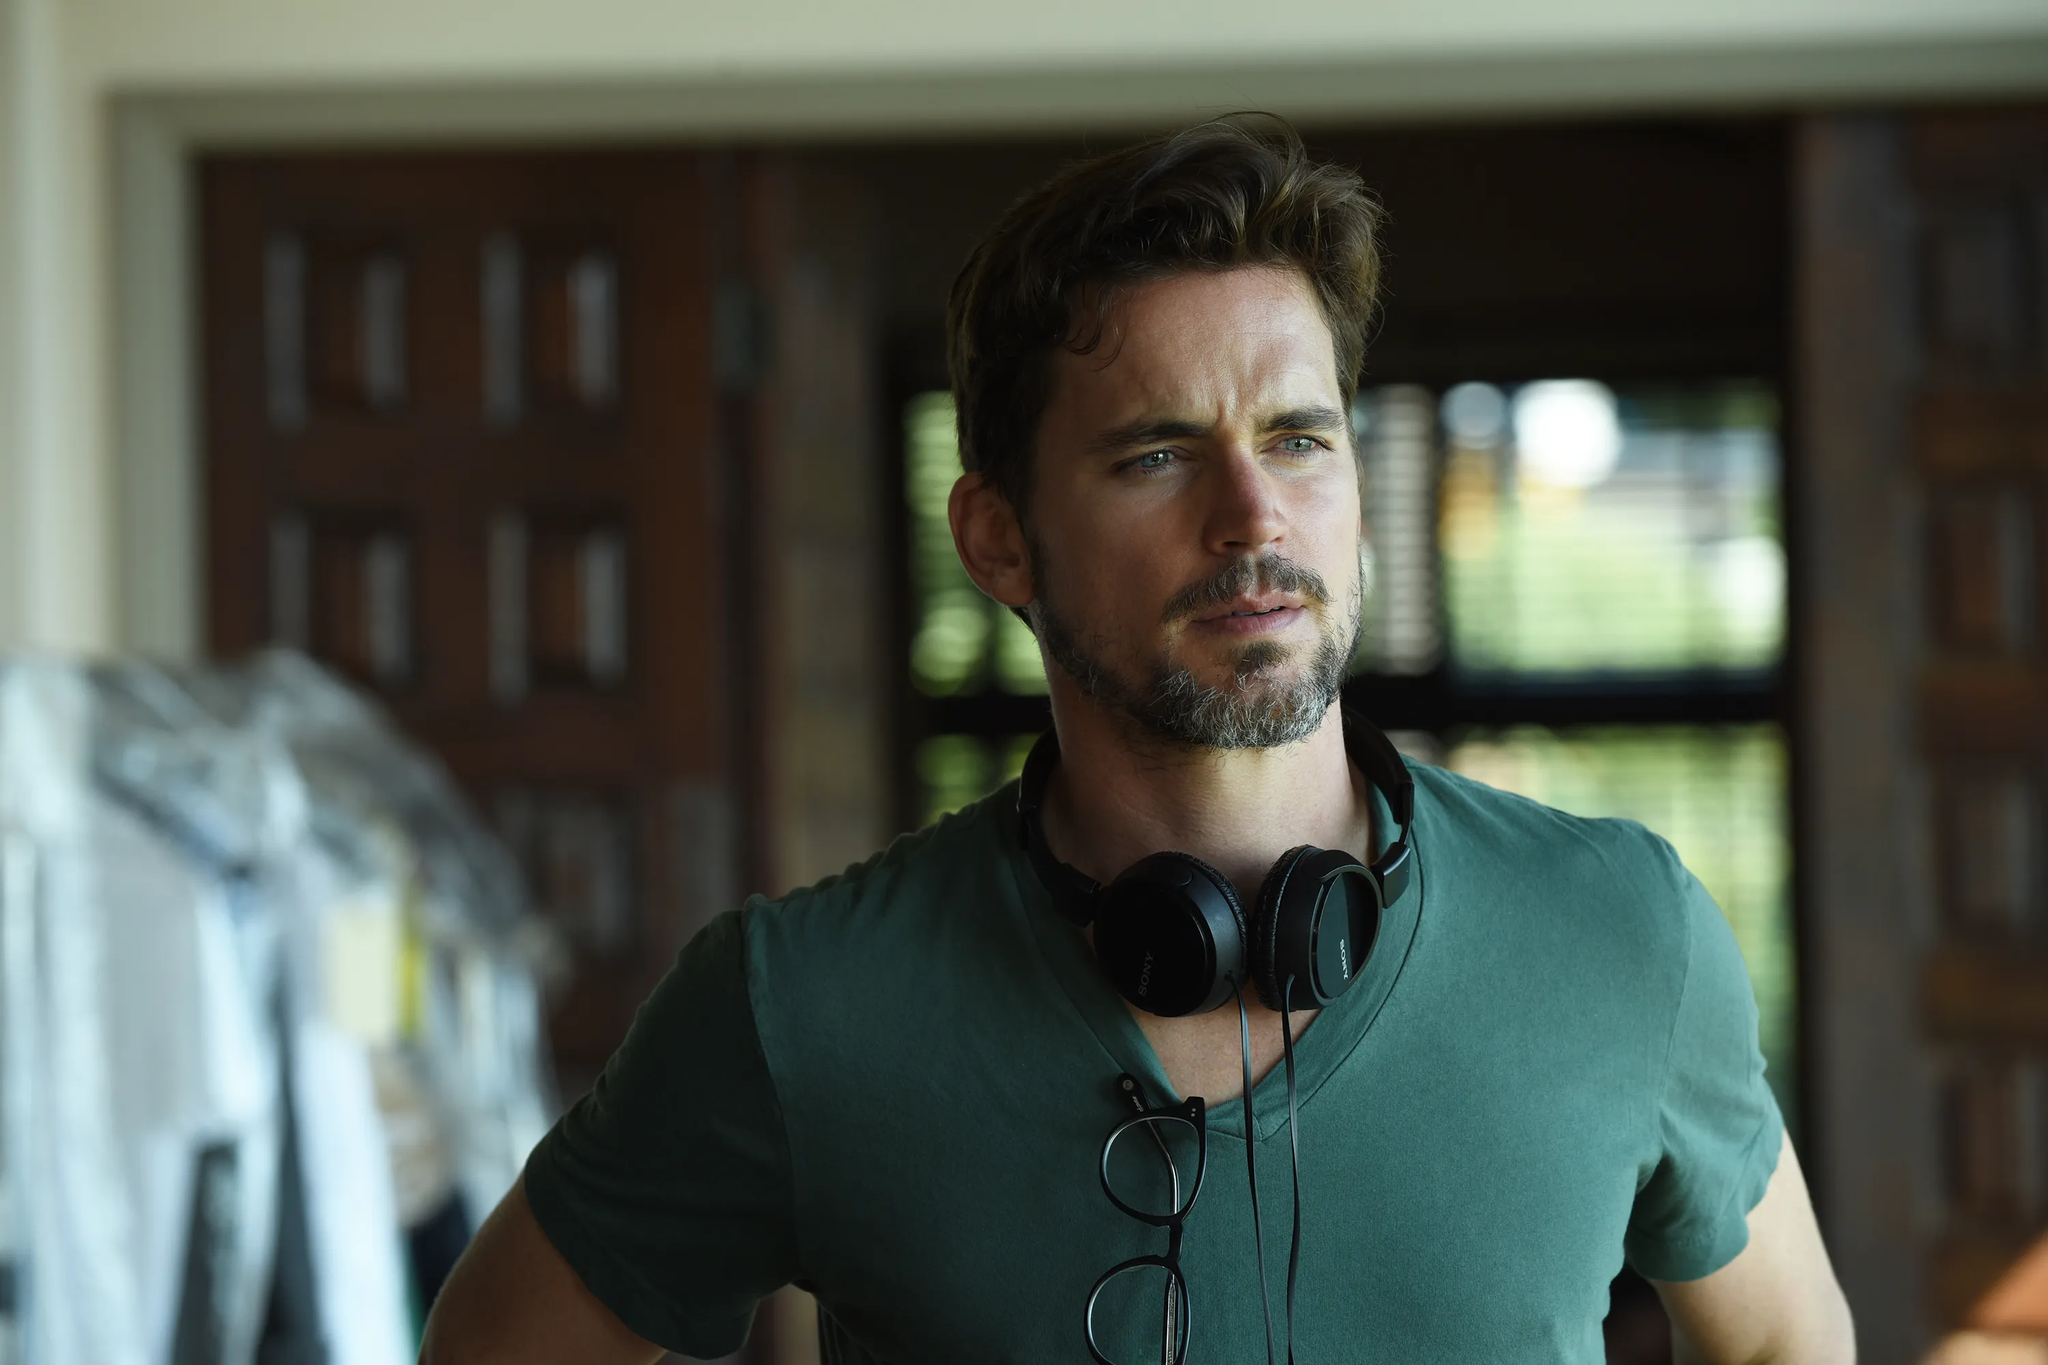What's happening in this image? The man in the image appears to be in a state of deep thought or contemplation. He might be preparing for something important or simply lost in his own thoughts. The headphones around his neck suggest he might be listening to or preparing to listen to music, possibly to get into a certain mood or mindset. 